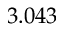Convert formula to latex. <formula><loc_0><loc_0><loc_500><loc_500>3 . 0 4 3</formula> 